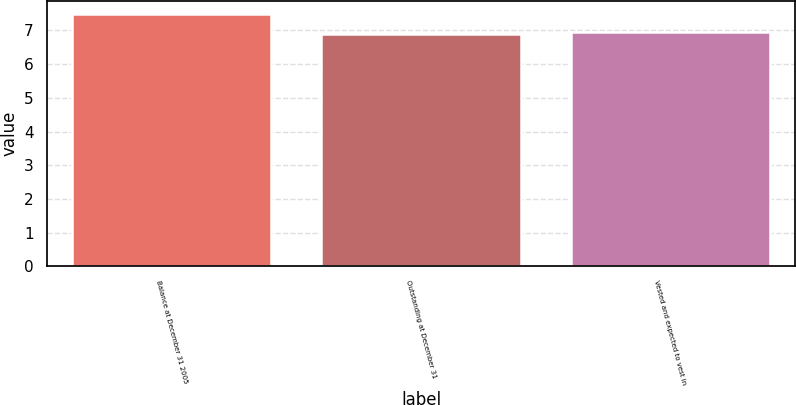Convert chart to OTSL. <chart><loc_0><loc_0><loc_500><loc_500><bar_chart><fcel>Balance at December 31 2005<fcel>Outstanding at December 31<fcel>Vested and expected to vest in<nl><fcel>7.5<fcel>6.9<fcel>6.96<nl></chart> 